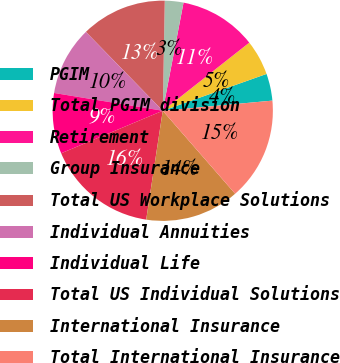Convert chart to OTSL. <chart><loc_0><loc_0><loc_500><loc_500><pie_chart><fcel>PGIM<fcel>Total PGIM division<fcel>Retirement<fcel>Group Insurance<fcel>Total US Workplace Solutions<fcel>Individual Annuities<fcel>Individual Life<fcel>Total US Individual Solutions<fcel>International Insurance<fcel>Total International Insurance<nl><fcel>3.96%<fcel>5.19%<fcel>11.36%<fcel>2.73%<fcel>12.59%<fcel>10.12%<fcel>8.89%<fcel>16.29%<fcel>13.82%<fcel>15.05%<nl></chart> 